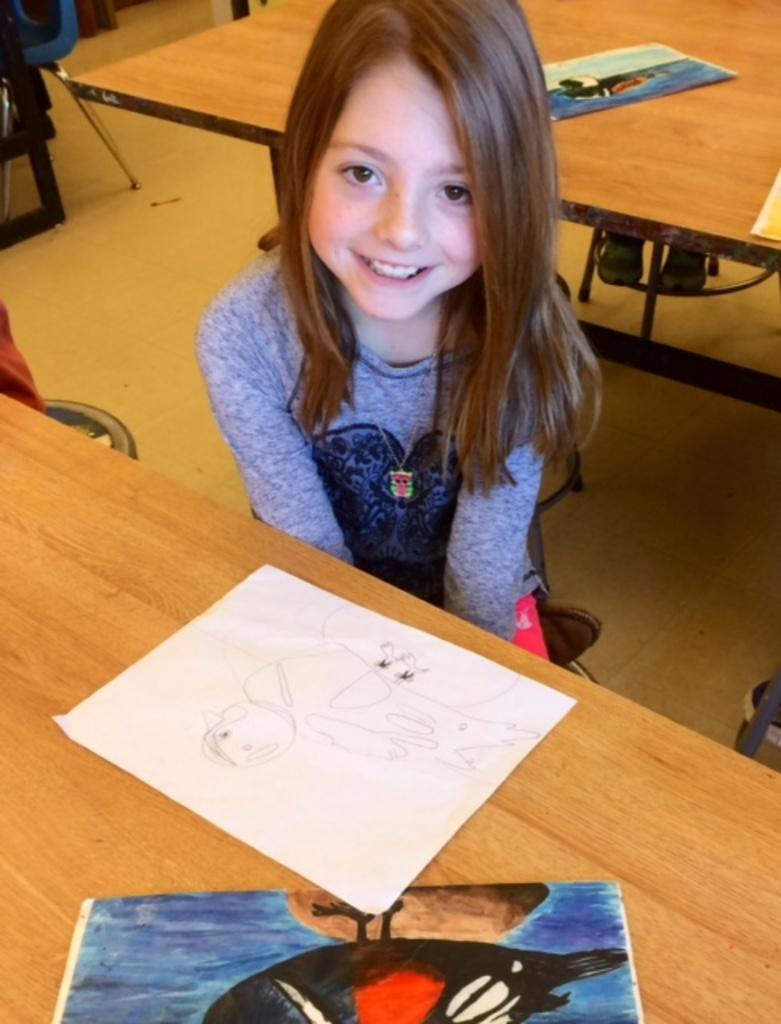Who is the main subject in the image? There is a girl in the image. What is the girl doing in the image? The girl is sitting on a chair. What furniture is present in the room? The room contains a table and a chair. What is on the table? There are papers on the table. What is the girl wearing? The girl is wearing a blue t-shirt and pink pants. What type of baseball game is the girl watching in the image? There is no baseball game present in the image; it features a girl sitting on a chair in a room with a table and papers. What season is it in the image, considering the girl's clothing? The girl's clothing (blue t-shirt and pink pants) does not provide any indication of the season. Is there a balloon visible in the image? No, there is no balloon present in the image. 